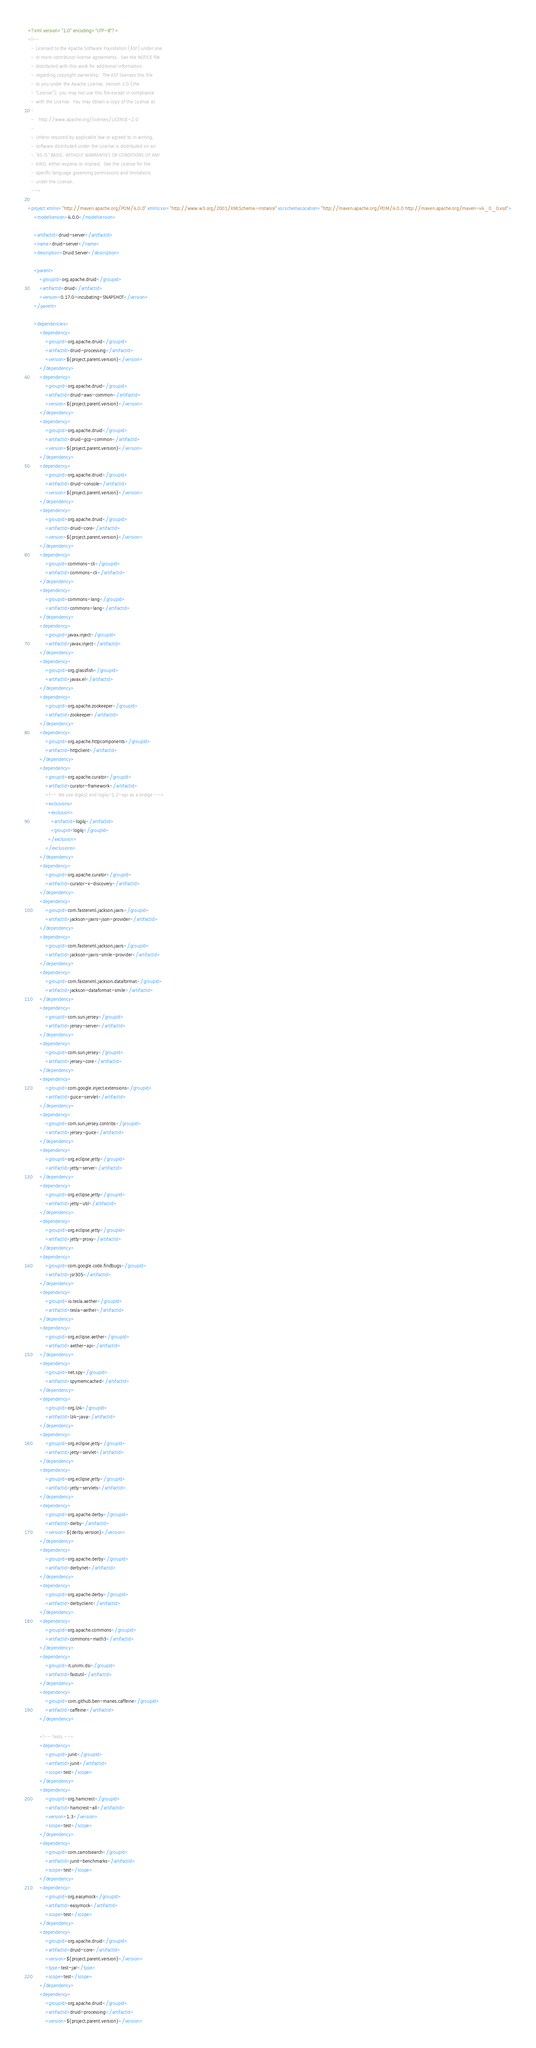Convert code to text. <code><loc_0><loc_0><loc_500><loc_500><_XML_><?xml version="1.0" encoding="UTF-8"?>
<!--
  ~ Licensed to the Apache Software Foundation (ASF) under one
  ~ or more contributor license agreements.  See the NOTICE file
  ~ distributed with this work for additional information
  ~ regarding copyright ownership.  The ASF licenses this file
  ~ to you under the Apache License, Version 2.0 (the
  ~ "License"); you may not use this file except in compliance
  ~ with the License.  You may obtain a copy of the License at
  ~
  ~   http://www.apache.org/licenses/LICENSE-2.0
  ~
  ~ Unless required by applicable law or agreed to in writing,
  ~ software distributed under the License is distributed on an
  ~ "AS IS" BASIS, WITHOUT WARRANTIES OR CONDITIONS OF ANY
  ~ KIND, either express or implied.  See the License for the
  ~ specific language governing permissions and limitations
  ~ under the License.
  -->

<project xmlns="http://maven.apache.org/POM/4.0.0" xmlns:xsi="http://www.w3.org/2001/XMLSchema-instance" xsi:schemaLocation="http://maven.apache.org/POM/4.0.0 http://maven.apache.org/maven-v4_0_0.xsd">
    <modelVersion>4.0.0</modelVersion>

    <artifactId>druid-server</artifactId>
    <name>druid-server</name>
    <description>Druid Server</description>

    <parent>
        <groupId>org.apache.druid</groupId>
        <artifactId>druid</artifactId>
        <version>0.17.0-incubating-SNAPSHOT</version>
    </parent>

    <dependencies>
        <dependency>
            <groupId>org.apache.druid</groupId>
            <artifactId>druid-processing</artifactId>
            <version>${project.parent.version}</version>
        </dependency>
        <dependency>
            <groupId>org.apache.druid</groupId>
            <artifactId>druid-aws-common</artifactId>
            <version>${project.parent.version}</version>
        </dependency>
        <dependency>
            <groupId>org.apache.druid</groupId>
            <artifactId>druid-gcp-common</artifactId>
            <version>${project.parent.version}</version>
        </dependency>
        <dependency>
            <groupId>org.apache.druid</groupId>
            <artifactId>druid-console</artifactId>
            <version>${project.parent.version}</version>
        </dependency>
        <dependency>
            <groupId>org.apache.druid</groupId>
            <artifactId>druid-core</artifactId>
            <version>${project.parent.version}</version>
        </dependency>
        <dependency>
            <groupId>commons-cli</groupId>
            <artifactId>commons-cli</artifactId>
        </dependency>
        <dependency>
            <groupId>commons-lang</groupId>
            <artifactId>commons-lang</artifactId>
        </dependency>
        <dependency>
            <groupId>javax.inject</groupId>
            <artifactId>javax.inject</artifactId>
        </dependency>
        <dependency>
            <groupId>org.glassfish</groupId>
            <artifactId>javax.el</artifactId>
        </dependency>
        <dependency>
            <groupId>org.apache.zookeeper</groupId>
            <artifactId>zookeeper</artifactId>
        </dependency>
        <dependency>
            <groupId>org.apache.httpcomponents</groupId>
            <artifactId>httpclient</artifactId>
        </dependency>
        <dependency>
            <groupId>org.apache.curator</groupId>
            <artifactId>curator-framework</artifactId>
            <!-- We use log4j2 and log4j-1.2-api as a bridge -->
            <exclusions>
              <exclusion>
                <artifactId>log4j</artifactId>
                <groupId>log4j</groupId>
              </exclusion>
            </exclusions>
        </dependency>
        <dependency>
            <groupId>org.apache.curator</groupId>
            <artifactId>curator-x-discovery</artifactId>
        </dependency>
        <dependency>
            <groupId>com.fasterxml.jackson.jaxrs</groupId>
            <artifactId>jackson-jaxrs-json-provider</artifactId>
        </dependency>
        <dependency>
            <groupId>com.fasterxml.jackson.jaxrs</groupId>
            <artifactId>jackson-jaxrs-smile-provider</artifactId>
        </dependency>
        <dependency>
            <groupId>com.fasterxml.jackson.dataformat</groupId>
            <artifactId>jackson-dataformat-smile</artifactId>
        </dependency>
        <dependency>
            <groupId>com.sun.jersey</groupId>
            <artifactId>jersey-server</artifactId>
        </dependency>
        <dependency>
            <groupId>com.sun.jersey</groupId>
            <artifactId>jersey-core</artifactId>
        </dependency>
        <dependency>
            <groupId>com.google.inject.extensions</groupId>
            <artifactId>guice-servlet</artifactId>
        </dependency>
        <dependency>
            <groupId>com.sun.jersey.contribs</groupId>
            <artifactId>jersey-guice</artifactId>
        </dependency>
        <dependency>
            <groupId>org.eclipse.jetty</groupId>
            <artifactId>jetty-server</artifactId>
        </dependency>
        <dependency>
            <groupId>org.eclipse.jetty</groupId>
            <artifactId>jetty-util</artifactId>
        </dependency>
        <dependency>
            <groupId>org.eclipse.jetty</groupId>
            <artifactId>jetty-proxy</artifactId>
        </dependency>
        <dependency>
            <groupId>com.google.code.findbugs</groupId>
            <artifactId>jsr305</artifactId>
        </dependency>
        <dependency>
            <groupId>io.tesla.aether</groupId>
            <artifactId>tesla-aether</artifactId>
        </dependency>
        <dependency>
            <groupId>org.eclipse.aether</groupId>
            <artifactId>aether-api</artifactId>
        </dependency>
        <dependency>
            <groupId>net.spy</groupId>
            <artifactId>spymemcached</artifactId>
        </dependency>
        <dependency>
            <groupId>org.lz4</groupId>
            <artifactId>lz4-java</artifactId>
        </dependency>
        <dependency>
            <groupId>org.eclipse.jetty</groupId>
            <artifactId>jetty-servlet</artifactId>
        </dependency>
        <dependency>
            <groupId>org.eclipse.jetty</groupId>
            <artifactId>jetty-servlets</artifactId>
        </dependency>
        <dependency>
            <groupId>org.apache.derby</groupId>
            <artifactId>derby</artifactId>
            <version>${derby.version}</version>
        </dependency>
        <dependency>
            <groupId>org.apache.derby</groupId>
            <artifactId>derbynet</artifactId>
        </dependency>
        <dependency>
            <groupId>org.apache.derby</groupId>
            <artifactId>derbyclient</artifactId>
        </dependency>
        <dependency>
            <groupId>org.apache.commons</groupId>
            <artifactId>commons-math3</artifactId>
        </dependency>
        <dependency>
            <groupId>it.unimi.dsi</groupId>
            <artifactId>fastutil</artifactId>
        </dependency>
        <dependency>
            <groupId>com.github.ben-manes.caffeine</groupId>
            <artifactId>caffeine</artifactId>
        </dependency>

        <!-- Tests -->
        <dependency>
            <groupId>junit</groupId>
            <artifactId>junit</artifactId>
            <scope>test</scope>
        </dependency>
        <dependency>
            <groupId>org.hamcrest</groupId>
            <artifactId>hamcrest-all</artifactId>
            <version>1.3</version>
            <scope>test</scope>
        </dependency>
        <dependency>
            <groupId>com.carrotsearch</groupId>
            <artifactId>junit-benchmarks</artifactId>
            <scope>test</scope>
        </dependency>
        <dependency>
            <groupId>org.easymock</groupId>
            <artifactId>easymock</artifactId>
            <scope>test</scope>
        </dependency>
        <dependency>
            <groupId>org.apache.druid</groupId>
            <artifactId>druid-core</artifactId>
            <version>${project.parent.version}</version>
            <type>test-jar</type>
            <scope>test</scope>
        </dependency>
        <dependency>
            <groupId>org.apache.druid</groupId>
            <artifactId>druid-processing</artifactId>
            <version>${project.parent.version}</version></code> 